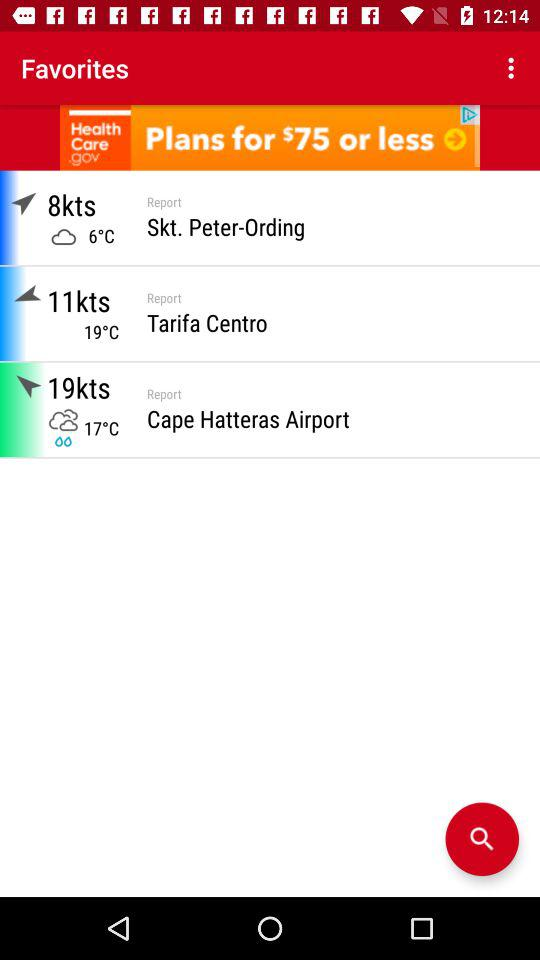How many more knots is the wind speed at Cape Hatteras Airport than at Skt. Peter-Ording?
Answer the question using a single word or phrase. 11 